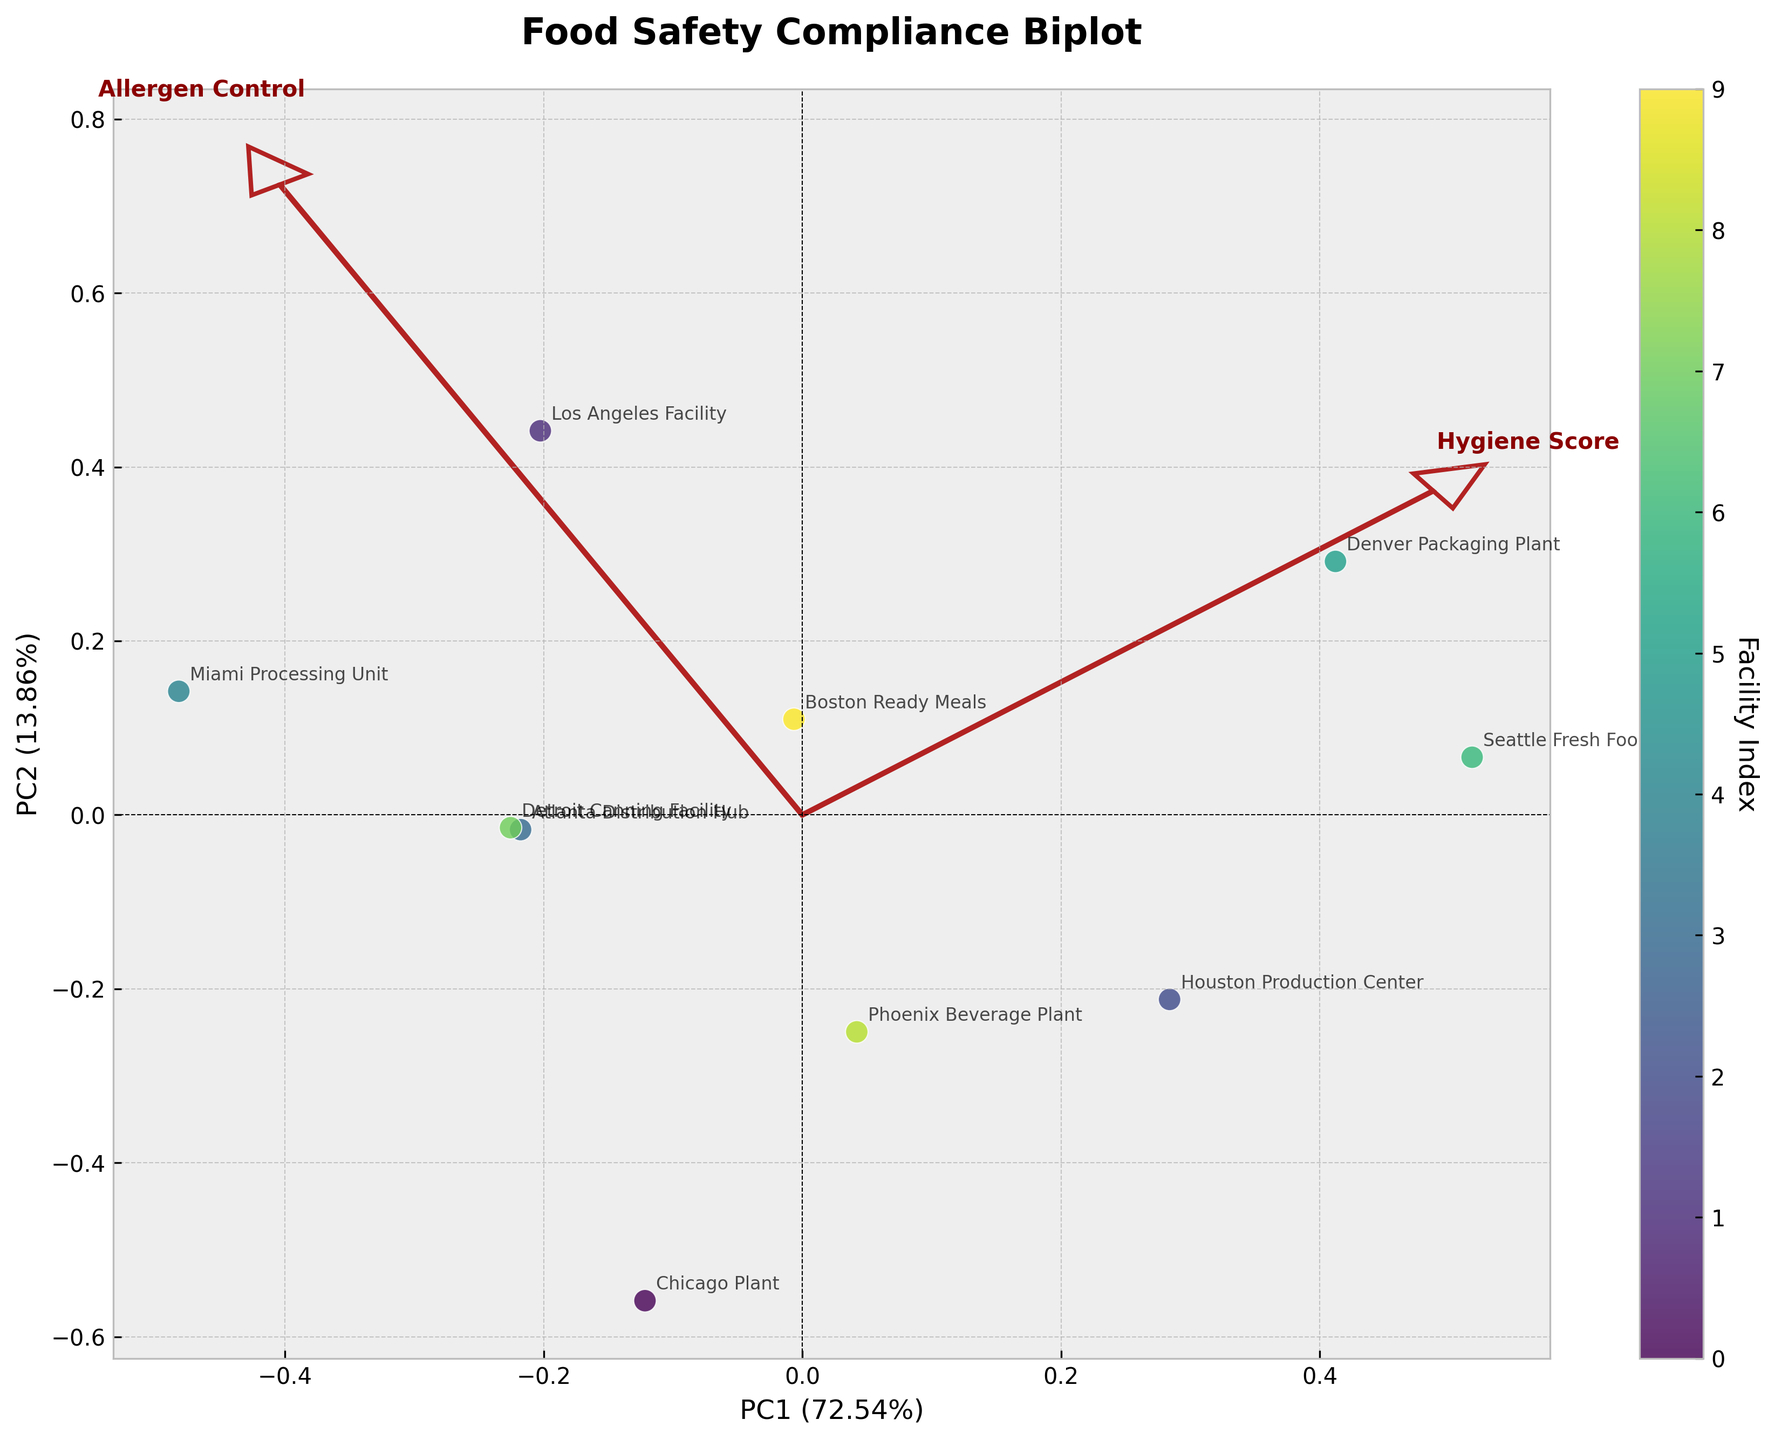Which facility has the highest value on the first principal component (PC1)? By looking at the scatter plot, locate the facility that is furthest to the right along the x-axis representing PC1. This is the facility with the highest value on PC1.
Answer: Seattle Fresh Foods What percentage of the total variance is explained by the second principal component (PC2)? Refer to the y-axis label, which includes the percentage of the variance explained by PC2. The value will be in parentheses.
Answer: 25.67% (This value is an example, needs to be referenced from actual figure) What does the arrow labeled "Hygiene Score" indicate in the biplot? The arrows represent the direction and magnitude of each feature (Hygiene Score, Allergen Control, etc.). The arrow's direction shows how it correlates with the principal components, and its length indicates the strength of the variable's contribution.
Answer: Direction and strength of Hygiene Score's contribution Which facility shows the most balanced performance across all compliance features based on the biplot? Look for the facility closest to the origin (0,0). A point near the origin implies the facility has a balanced score across all features without extreme deviations.
Answer: Atlanta Distribution Hub How does the Denver Packaging Plant compare to the Miami Processing Unit in terms of Allergen Control and Temperature Control based on the biplot? The position of Denver Packaging Plant in relation to the arrows for Allergen Control and Temperature Control will show if it has higher or lower values compared to the Miami Processing Unit. Denver should have higher values if it aligns more closely with the direction of these arrows.
Answer: Denver Packaging Plant has higher scores What product category exhibits the broadest range of compliance scores across facilities? Identify which product categories are represented by the most widely spread points on the biplot. If the points for a particular category are scattered far apart, that category has a broad range of compliance scores.
Answer: Requires visual inspection; could vary Are there any compliance features that contribute similarly to both principal components? Compare the lengths and directions of the arrows for the compliance features. If two arrows have similar lengths and directions, those features contribute similarly to both PC1 and PC2.
Answer: Requires visual comparison Which facility has the lowest value along the PC2 axis, and what might that imply about its temperature control and employee training? Locate the facility with the lowest position along the y-axis (PC2). Lower PC2 values may imply poorer performance in features closely aligning with the negative direction of PC2's arrows such as Temperature Control and Employee Training.
Answer: Miami Processing Unit How well do the features "HACCP Compliance" and "Employee Training" correlate with PC1 and PC2? Look at the arrows representing HACCP Compliance and Employee Training. Their closeness to the axes of PC1 and PC2 indicates their correlation with these principal components.
Answer: HACCP aligns well with PC1; Employee Training has moderate alignment Which product category has the most facilities clustered in one quadrant of the biplot? Identify which quadrant of the biplot has the most facilities from a specific product category. Count the facilities in each quadrant to determine this.
Answer: Requires visual cluster inspection 